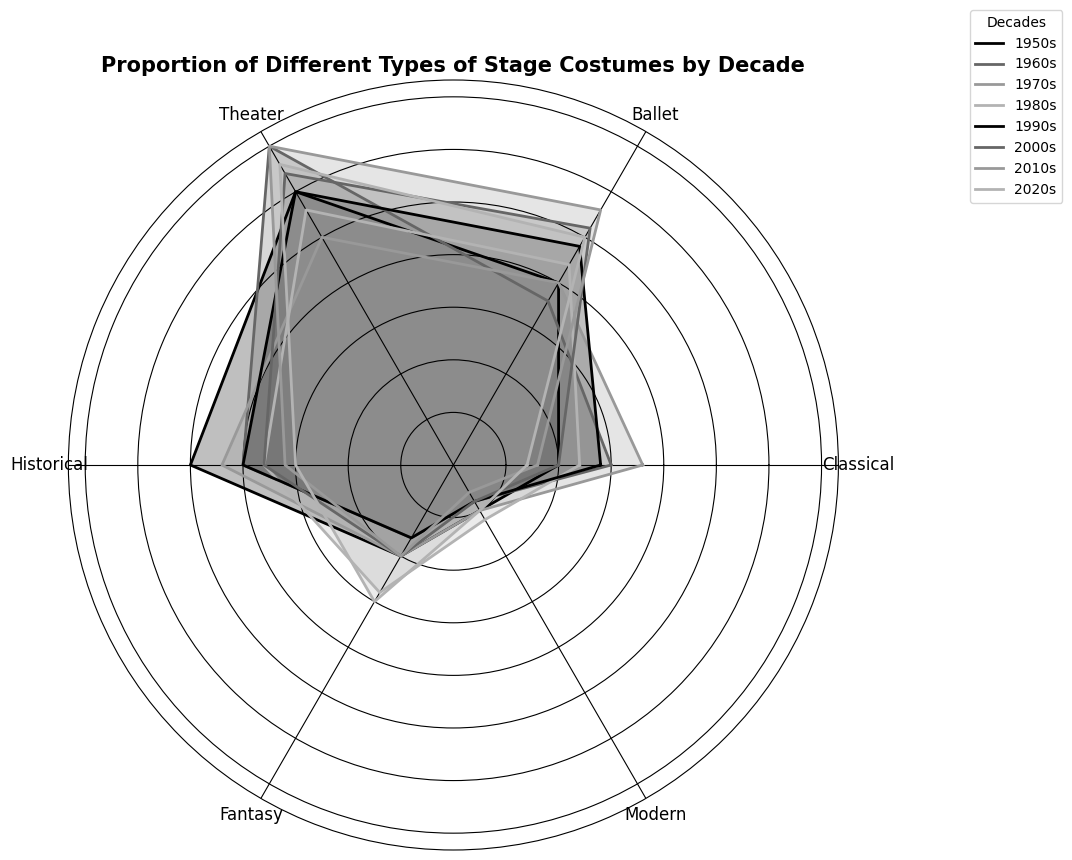What is the dominant stage costume type in the 2020s? By observing the lengths of the segments for the 2020s, the longest segment corresponds to the Fantasy category.
Answer: Fantasy Which decade has the smallest proportion of modern costumes? By comparing the lengths of the segments for the Modern category across all decades, the smallest segment is in the 2010s.
Answer: 2010s What are the differences in the proportions of Ballet costumes between the 1960s and 2000s? Noting the lengths of the Ballet segments for the 1960s and 2000s, the proportions are 18 and 26 respectively. The difference is 26 - 18 = 8.
Answer: 8 Which costume type shows the most consistent proportion across all decades? Identify the category with the segments that vary least visually across the rings. Modern consistently shows small variations from 3 to 6.
Answer: Modern During which decade did the Historical costumes have their highest proportion? Look at the longest segments in the Historical category; the highest proportion is in the 1950s.
Answer: 1950s During which decade did the Ballet costumes reach their peak proportion? The longest segment for Ballet is in the 2010s at 28.
Answer: 2010s By how much did the proportion of Classical costumes decrease from the 1950s to the 2020s? Observing the Classical segments:
- 1950s: 10
- 2020s: 7
Difference: 10 - 7 = 3
Answer: 3 